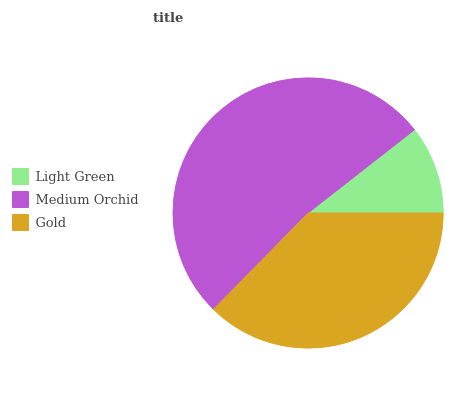Is Light Green the minimum?
Answer yes or no. Yes. Is Medium Orchid the maximum?
Answer yes or no. Yes. Is Gold the minimum?
Answer yes or no. No. Is Gold the maximum?
Answer yes or no. No. Is Medium Orchid greater than Gold?
Answer yes or no. Yes. Is Gold less than Medium Orchid?
Answer yes or no. Yes. Is Gold greater than Medium Orchid?
Answer yes or no. No. Is Medium Orchid less than Gold?
Answer yes or no. No. Is Gold the high median?
Answer yes or no. Yes. Is Gold the low median?
Answer yes or no. Yes. Is Light Green the high median?
Answer yes or no. No. Is Light Green the low median?
Answer yes or no. No. 